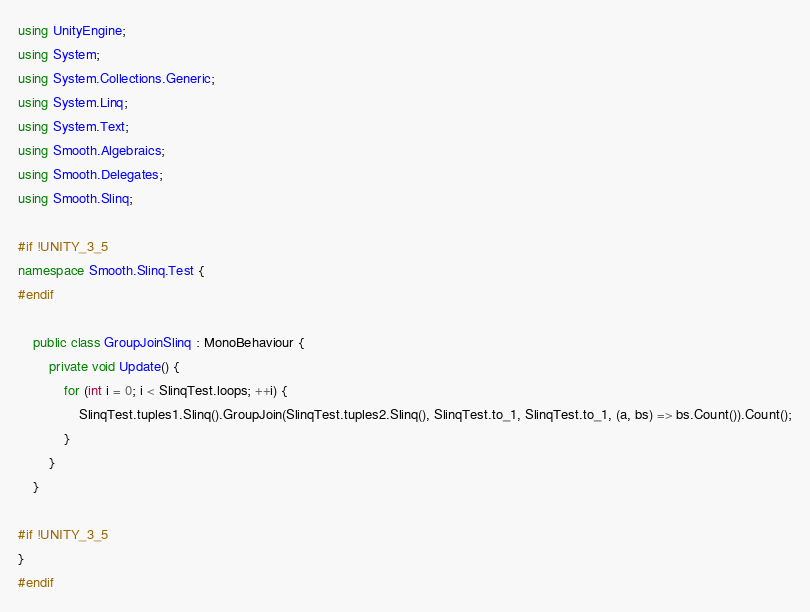Convert code to text. <code><loc_0><loc_0><loc_500><loc_500><_C#_>using UnityEngine;
using System;
using System.Collections.Generic;
using System.Linq;
using System.Text;
using Smooth.Algebraics;
using Smooth.Delegates;
using Smooth.Slinq;

#if !UNITY_3_5
namespace Smooth.Slinq.Test {
#endif
	
	public class GroupJoinSlinq : MonoBehaviour {
		private void Update() {
			for (int i = 0; i < SlinqTest.loops; ++i) {
				SlinqTest.tuples1.Slinq().GroupJoin(SlinqTest.tuples2.Slinq(), SlinqTest.to_1, SlinqTest.to_1, (a, bs) => bs.Count()).Count();
			}
		}
	}

#if !UNITY_3_5
}
#endif
</code> 